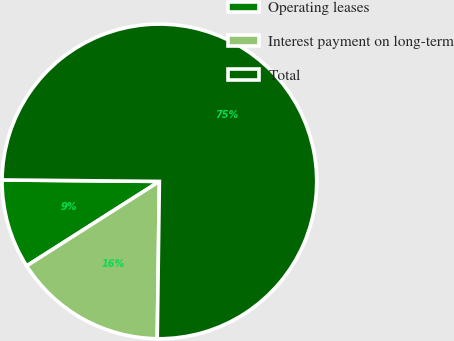Convert chart. <chart><loc_0><loc_0><loc_500><loc_500><pie_chart><fcel>Operating leases<fcel>Interest payment on long-term<fcel>Total<nl><fcel>9.17%<fcel>15.76%<fcel>75.07%<nl></chart> 